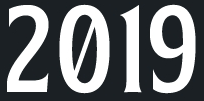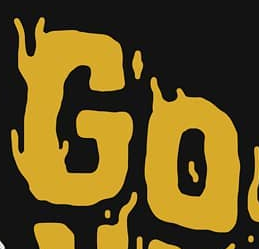What text appears in these images from left to right, separated by a semicolon? 2019; GO 